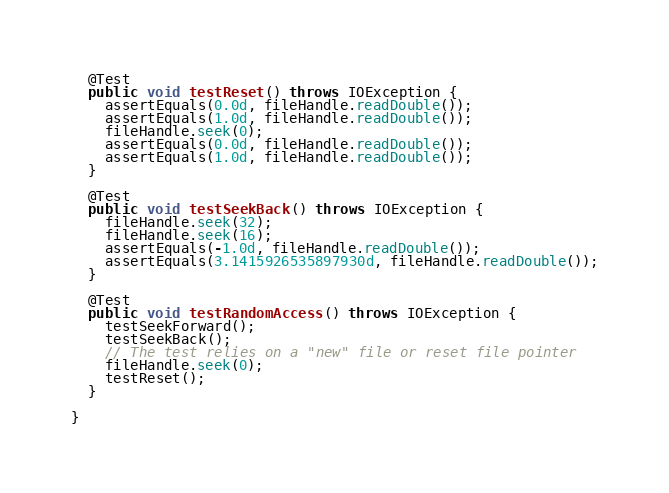Convert code to text. <code><loc_0><loc_0><loc_500><loc_500><_Java_>
  @Test
  public void testReset() throws IOException {
    assertEquals(0.0d, fileHandle.readDouble());
    assertEquals(1.0d, fileHandle.readDouble());
    fileHandle.seek(0);
    assertEquals(0.0d, fileHandle.readDouble());
    assertEquals(1.0d, fileHandle.readDouble());
  }

  @Test
  public void testSeekBack() throws IOException {
    fileHandle.seek(32);
    fileHandle.seek(16);
    assertEquals(-1.0d, fileHandle.readDouble());
    assertEquals(3.1415926535897930d, fileHandle.readDouble());
  }

  @Test
  public void testRandomAccess() throws IOException {
    testSeekForward();
    testSeekBack();
    // The test relies on a "new" file or reset file pointer
    fileHandle.seek(0);
    testReset();
  }

}
</code> 